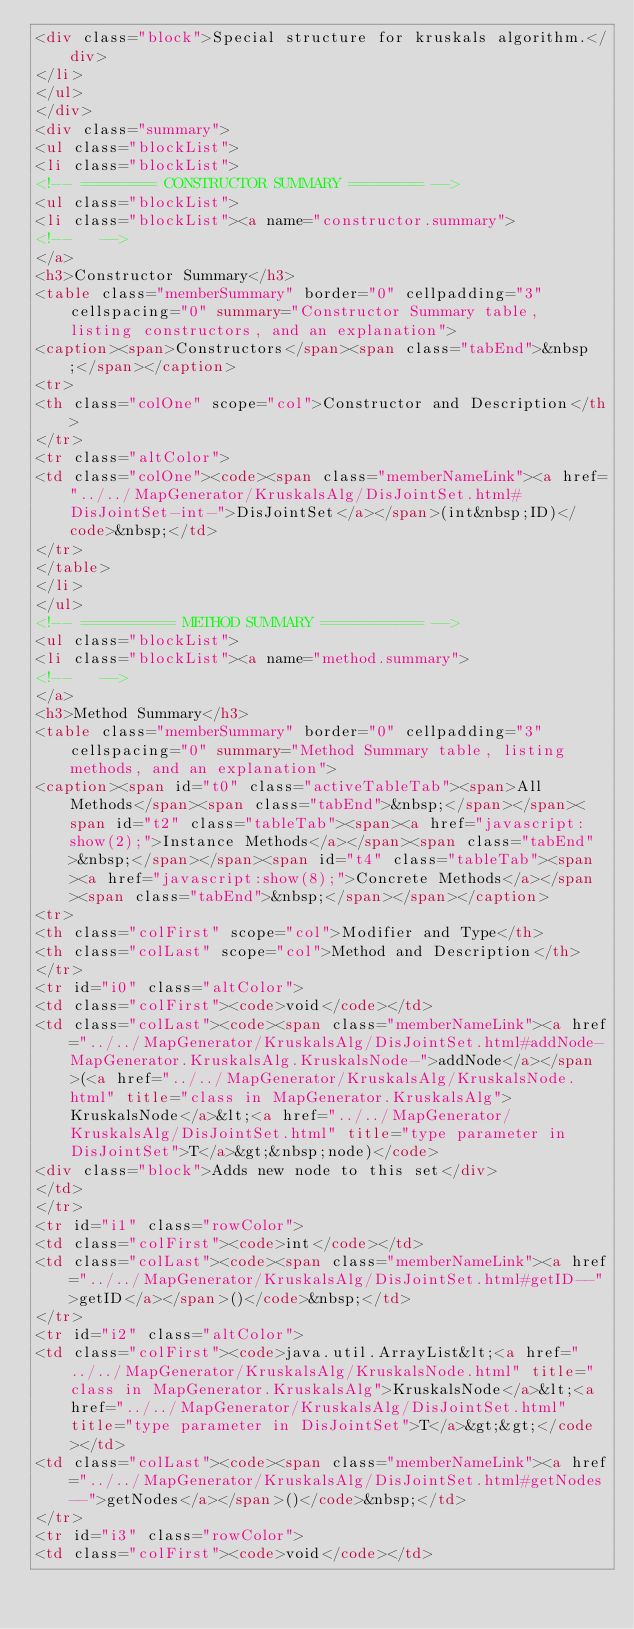<code> <loc_0><loc_0><loc_500><loc_500><_HTML_><div class="block">Special structure for kruskals algorithm.</div>
</li>
</ul>
</div>
<div class="summary">
<ul class="blockList">
<li class="blockList">
<!-- ======== CONSTRUCTOR SUMMARY ======== -->
<ul class="blockList">
<li class="blockList"><a name="constructor.summary">
<!--   -->
</a>
<h3>Constructor Summary</h3>
<table class="memberSummary" border="0" cellpadding="3" cellspacing="0" summary="Constructor Summary table, listing constructors, and an explanation">
<caption><span>Constructors</span><span class="tabEnd">&nbsp;</span></caption>
<tr>
<th class="colOne" scope="col">Constructor and Description</th>
</tr>
<tr class="altColor">
<td class="colOne"><code><span class="memberNameLink"><a href="../../MapGenerator/KruskalsAlg/DisJointSet.html#DisJointSet-int-">DisJointSet</a></span>(int&nbsp;ID)</code>&nbsp;</td>
</tr>
</table>
</li>
</ul>
<!-- ========== METHOD SUMMARY =========== -->
<ul class="blockList">
<li class="blockList"><a name="method.summary">
<!--   -->
</a>
<h3>Method Summary</h3>
<table class="memberSummary" border="0" cellpadding="3" cellspacing="0" summary="Method Summary table, listing methods, and an explanation">
<caption><span id="t0" class="activeTableTab"><span>All Methods</span><span class="tabEnd">&nbsp;</span></span><span id="t2" class="tableTab"><span><a href="javascript:show(2);">Instance Methods</a></span><span class="tabEnd">&nbsp;</span></span><span id="t4" class="tableTab"><span><a href="javascript:show(8);">Concrete Methods</a></span><span class="tabEnd">&nbsp;</span></span></caption>
<tr>
<th class="colFirst" scope="col">Modifier and Type</th>
<th class="colLast" scope="col">Method and Description</th>
</tr>
<tr id="i0" class="altColor">
<td class="colFirst"><code>void</code></td>
<td class="colLast"><code><span class="memberNameLink"><a href="../../MapGenerator/KruskalsAlg/DisJointSet.html#addNode-MapGenerator.KruskalsAlg.KruskalsNode-">addNode</a></span>(<a href="../../MapGenerator/KruskalsAlg/KruskalsNode.html" title="class in MapGenerator.KruskalsAlg">KruskalsNode</a>&lt;<a href="../../MapGenerator/KruskalsAlg/DisJointSet.html" title="type parameter in DisJointSet">T</a>&gt;&nbsp;node)</code>
<div class="block">Adds new node to this set</div>
</td>
</tr>
<tr id="i1" class="rowColor">
<td class="colFirst"><code>int</code></td>
<td class="colLast"><code><span class="memberNameLink"><a href="../../MapGenerator/KruskalsAlg/DisJointSet.html#getID--">getID</a></span>()</code>&nbsp;</td>
</tr>
<tr id="i2" class="altColor">
<td class="colFirst"><code>java.util.ArrayList&lt;<a href="../../MapGenerator/KruskalsAlg/KruskalsNode.html" title="class in MapGenerator.KruskalsAlg">KruskalsNode</a>&lt;<a href="../../MapGenerator/KruskalsAlg/DisJointSet.html" title="type parameter in DisJointSet">T</a>&gt;&gt;</code></td>
<td class="colLast"><code><span class="memberNameLink"><a href="../../MapGenerator/KruskalsAlg/DisJointSet.html#getNodes--">getNodes</a></span>()</code>&nbsp;</td>
</tr>
<tr id="i3" class="rowColor">
<td class="colFirst"><code>void</code></td></code> 